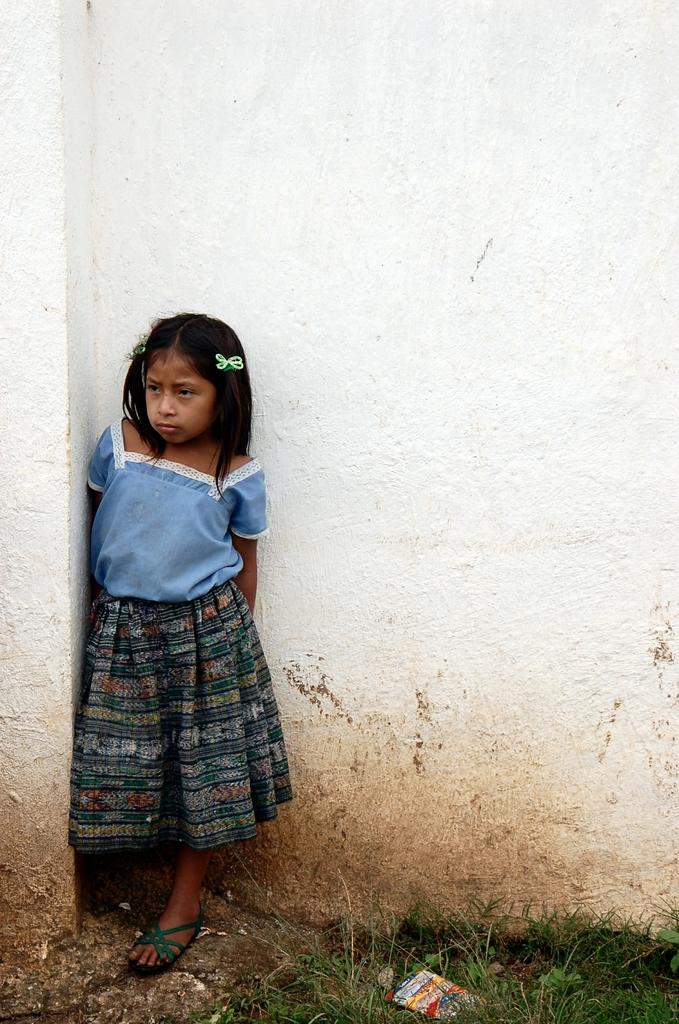What is the main subject in the image? There is a girl standing in the image. Can you describe the wall in the image? The wall in the image is white in color. What type of natural environment is visible at the bottom of the image? There is grass visible at the bottom of the image. What object is present at the bottom of the image, besides the grass? There is a paper at the bottom of the image. What type of toy is the girl playing with in the image? There is no toy visible in the image; the girl is simply standing. 